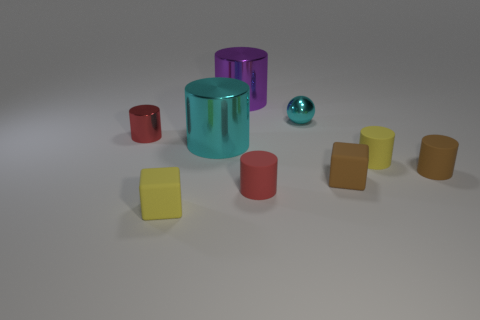How many objects are there in total, and could you describe their shapes? There are a total of nine objects in the image, comprising a mixture of shapes. Starting from the left, there are two cylinders—one red and one shimmering with purple and green hues. In front of them, there is a tiny sphere with a metallic blue shine. In the center, we see a large cylinder with a reflective cyan surface. Scattered around are five cubes: one red, three brown with varying shades, and one yellow. 